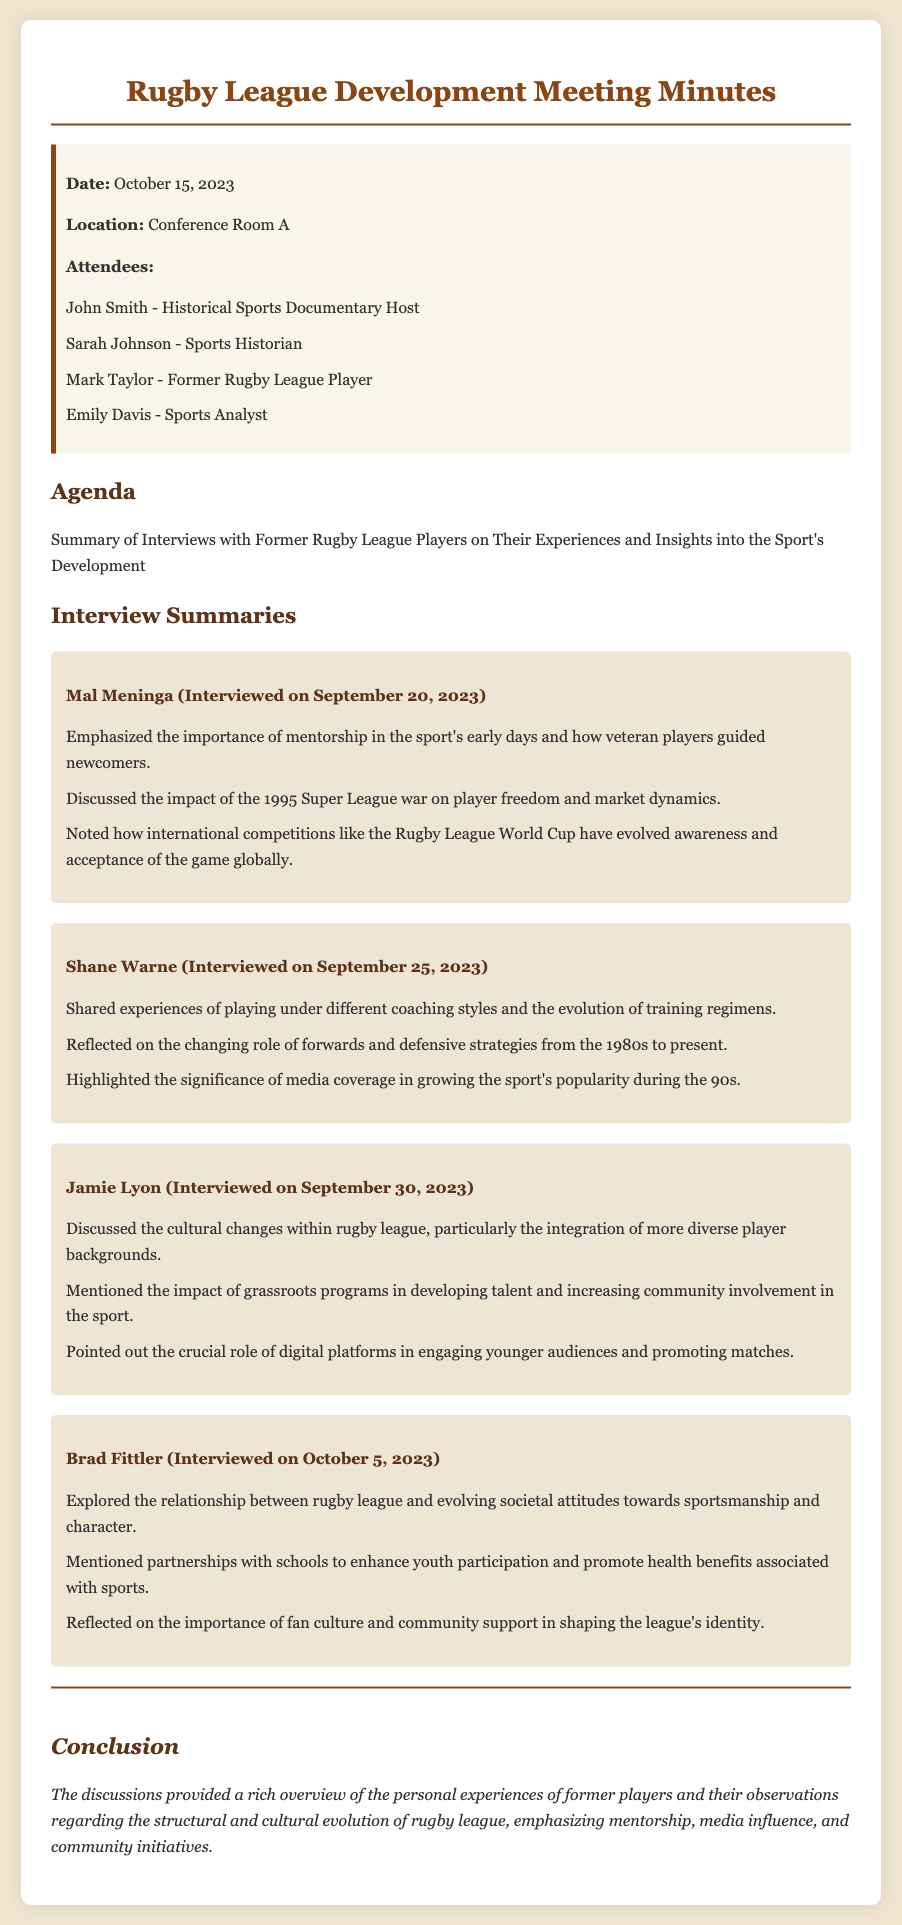What is the date of the meeting? The date is mentioned at the beginning of the document under the info section.
Answer: October 15, 2023 Who emphasized the importance of mentorship in rugby league? The player name is highlighted in the insights section discussing mentorship.
Answer: Mal Meninga What significant event did Mal Meninga discuss related to player freedom? The event is specifically mentioned in his insights, affecting market dynamics.
Answer: 1995 Super League war Which player reflected on changing coaching styles? The identity of the player is noted in the interview summaries related to coaching.
Answer: Shane Warne What was highlighted as crucial for engaging younger audiences? This information is included in Jamie Lyon's insights regarding digital platforms.
Answer: Digital platforms Who discussed the role of fan culture in shaping the league's identity? The player's insights reveal their focus on community support and fan culture.
Answer: Brad Fittler How many players were interviewed for the summaries? The count is derived from the number of player insights presented in the document.
Answer: Four What role do grassroots programs play according to Jamie Lyon? This is mentioned in context with talent development and community involvement.
Answer: Developing talent What aspect of rugby league did Brad Fittler primarily explore? His insights focus on societal attitudes towards sportsmanship and character.
Answer: Societal attitudes 